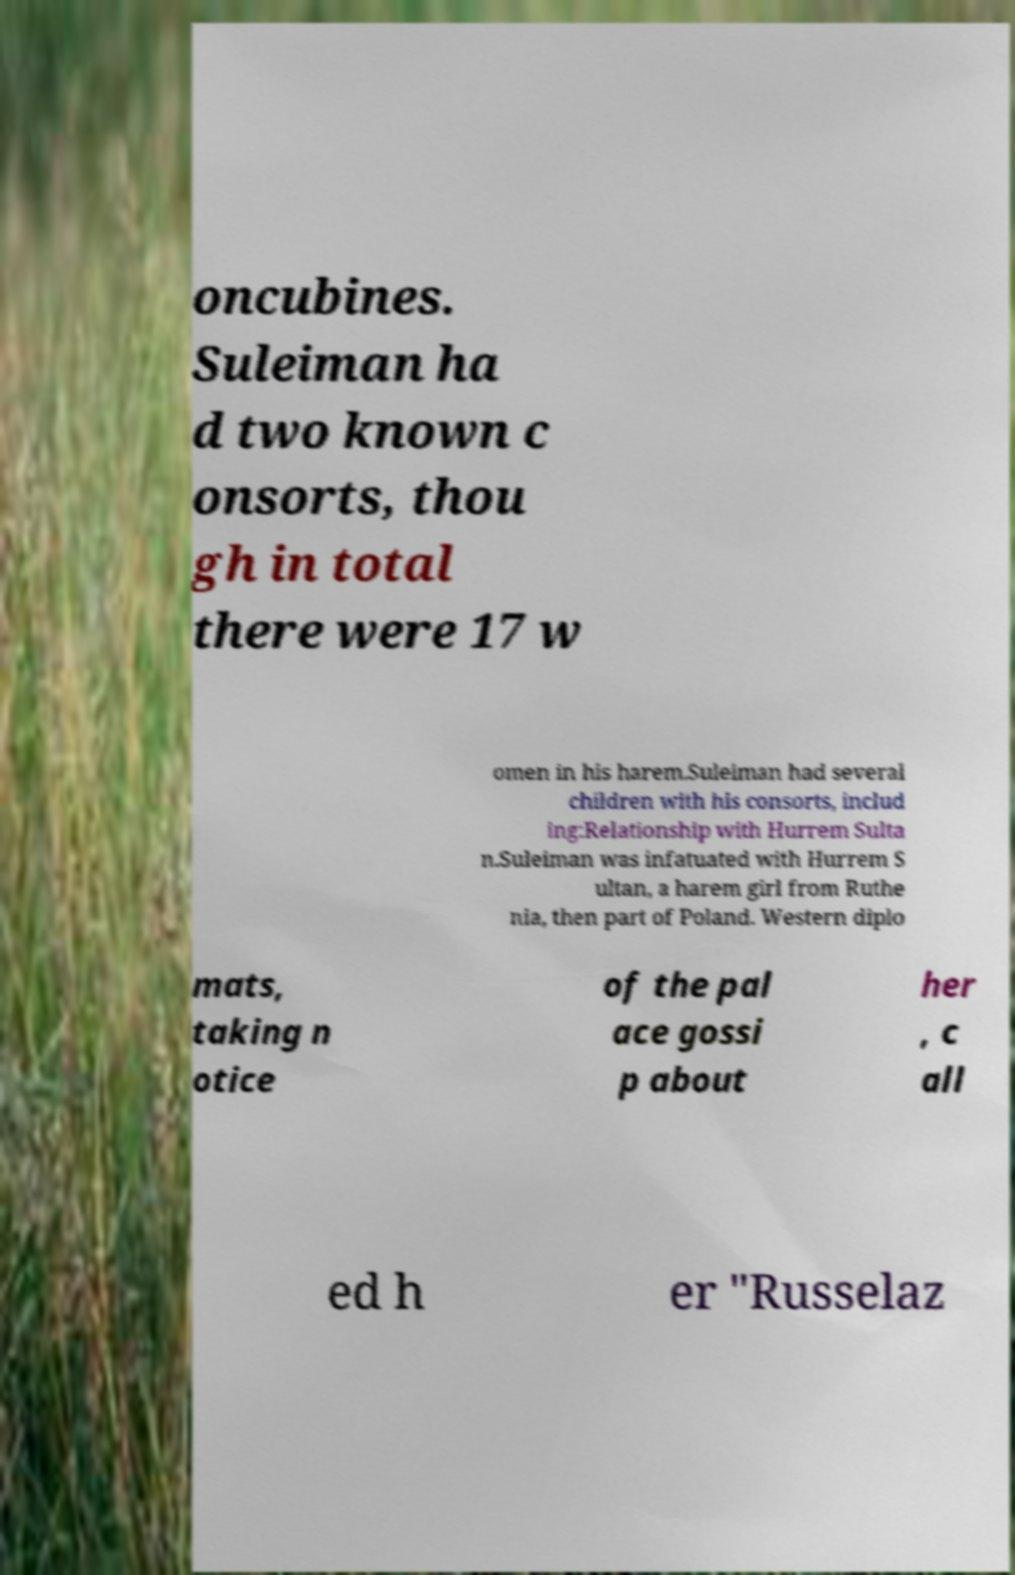Please read and relay the text visible in this image. What does it say? oncubines. Suleiman ha d two known c onsorts, thou gh in total there were 17 w omen in his harem.Suleiman had several children with his consorts, includ ing:Relationship with Hurrem Sulta n.Suleiman was infatuated with Hurrem S ultan, a harem girl from Ruthe nia, then part of Poland. Western diplo mats, taking n otice of the pal ace gossi p about her , c all ed h er "Russelaz 